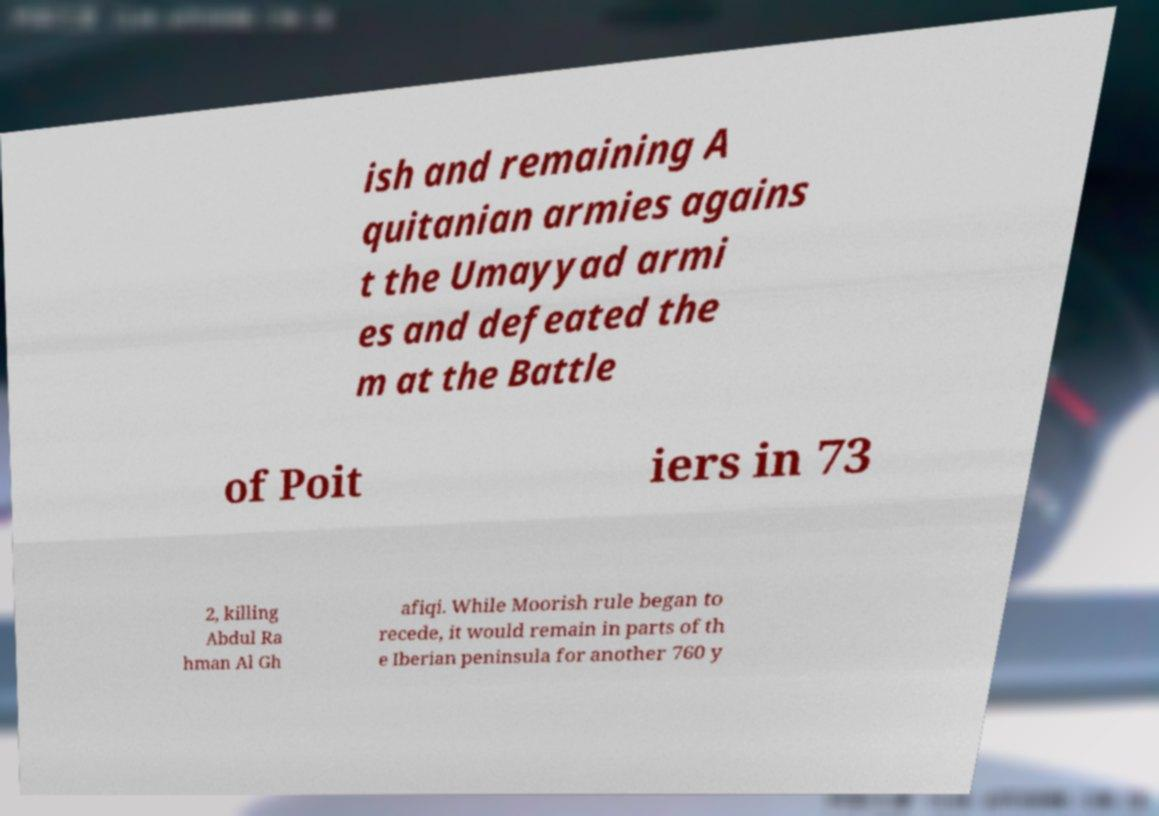Could you assist in decoding the text presented in this image and type it out clearly? ish and remaining A quitanian armies agains t the Umayyad armi es and defeated the m at the Battle of Poit iers in 73 2, killing Abdul Ra hman Al Gh afiqi. While Moorish rule began to recede, it would remain in parts of th e Iberian peninsula for another 760 y 